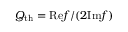Convert formula to latex. <formula><loc_0><loc_0><loc_500><loc_500>Q _ { t h } = R e f / ( 2 I m f )</formula> 